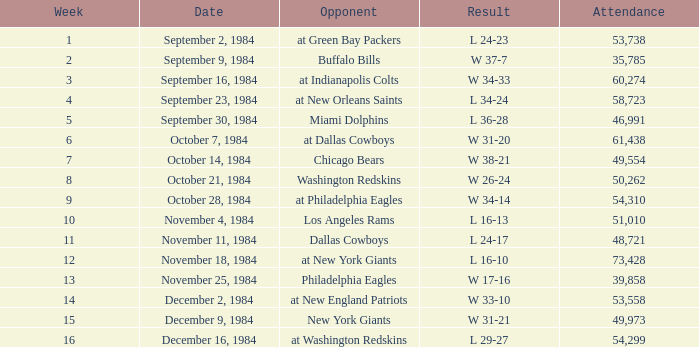I'm looking to parse the entire table for insights. Could you assist me with that? {'header': ['Week', 'Date', 'Opponent', 'Result', 'Attendance'], 'rows': [['1', 'September 2, 1984', 'at Green Bay Packers', 'L 24-23', '53,738'], ['2', 'September 9, 1984', 'Buffalo Bills', 'W 37-7', '35,785'], ['3', 'September 16, 1984', 'at Indianapolis Colts', 'W 34-33', '60,274'], ['4', 'September 23, 1984', 'at New Orleans Saints', 'L 34-24', '58,723'], ['5', 'September 30, 1984', 'Miami Dolphins', 'L 36-28', '46,991'], ['6', 'October 7, 1984', 'at Dallas Cowboys', 'W 31-20', '61,438'], ['7', 'October 14, 1984', 'Chicago Bears', 'W 38-21', '49,554'], ['8', 'October 21, 1984', 'Washington Redskins', 'W 26-24', '50,262'], ['9', 'October 28, 1984', 'at Philadelphia Eagles', 'W 34-14', '54,310'], ['10', 'November 4, 1984', 'Los Angeles Rams', 'L 16-13', '51,010'], ['11', 'November 11, 1984', 'Dallas Cowboys', 'L 24-17', '48,721'], ['12', 'November 18, 1984', 'at New York Giants', 'L 16-10', '73,428'], ['13', 'November 25, 1984', 'Philadelphia Eagles', 'W 17-16', '39,858'], ['14', 'December 2, 1984', 'at New England Patriots', 'W 33-10', '53,558'], ['15', 'December 9, 1984', 'New York Giants', 'W 31-21', '49,973'], ['16', 'December 16, 1984', 'at Washington Redskins', 'L 29-27', '54,299']]} Who was the opponent on October 14, 1984? Chicago Bears. 